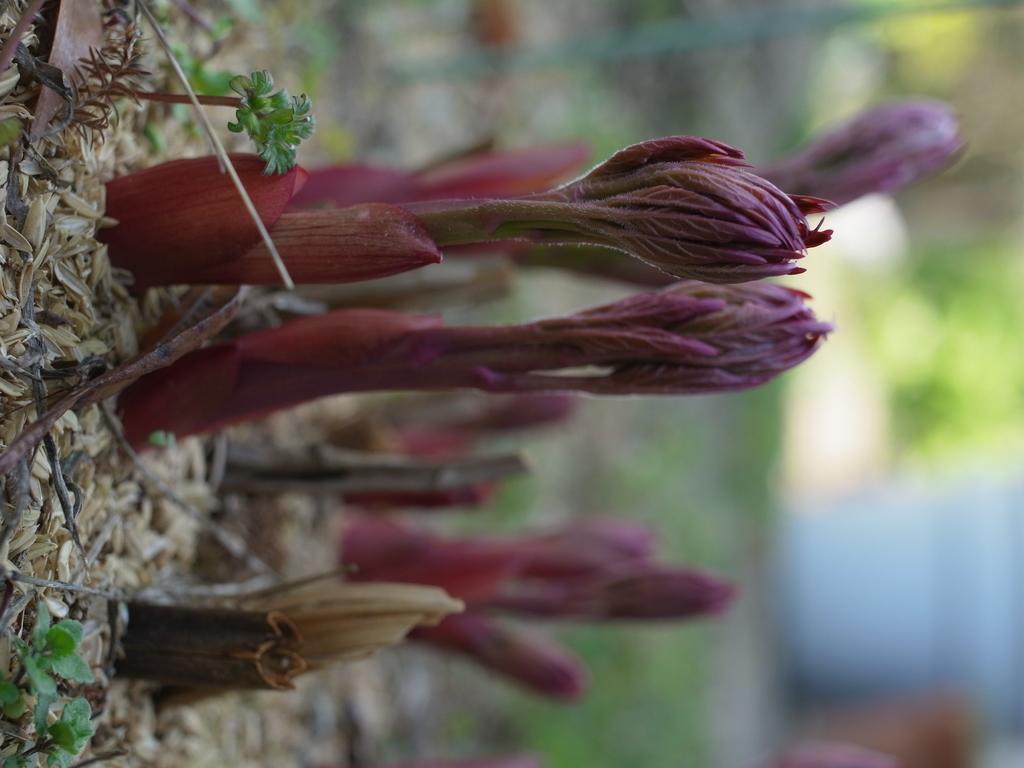Describe this image in one or two sentences. In this picture we can see a tilted image of a plant with magenta color flowers and leaves. We can see dry & green leaves, sticks on the ground. 